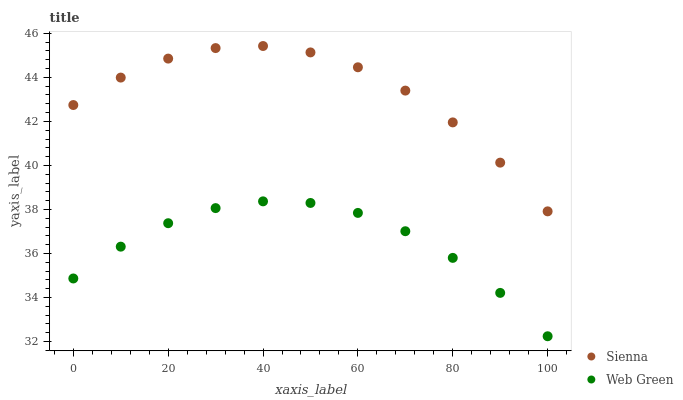Does Web Green have the minimum area under the curve?
Answer yes or no. Yes. Does Sienna have the maximum area under the curve?
Answer yes or no. Yes. Does Web Green have the maximum area under the curve?
Answer yes or no. No. Is Web Green the smoothest?
Answer yes or no. Yes. Is Sienna the roughest?
Answer yes or no. Yes. Is Web Green the roughest?
Answer yes or no. No. Does Web Green have the lowest value?
Answer yes or no. Yes. Does Sienna have the highest value?
Answer yes or no. Yes. Does Web Green have the highest value?
Answer yes or no. No. Is Web Green less than Sienna?
Answer yes or no. Yes. Is Sienna greater than Web Green?
Answer yes or no. Yes. Does Web Green intersect Sienna?
Answer yes or no. No. 